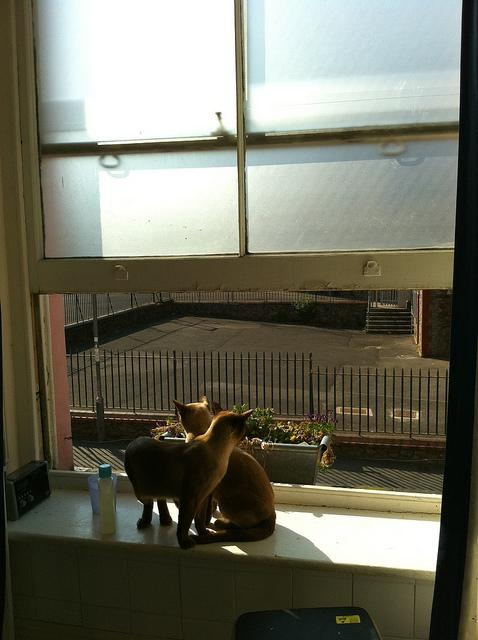How many Siamese cats are sitting atop the window cell? two 